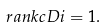Convert formula to latex. <formula><loc_0><loc_0><loc_500><loc_500>\ r a n k c D i = 1 .</formula> 